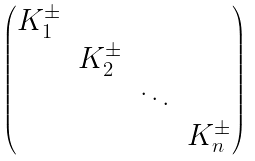<formula> <loc_0><loc_0><loc_500><loc_500>\begin{pmatrix} K ^ { \pm } _ { 1 } & & & \\ & K ^ { \pm } _ { 2 } & & \\ & & \ddots & \\ & & & K ^ { \pm } _ { n } \end{pmatrix}</formula> 